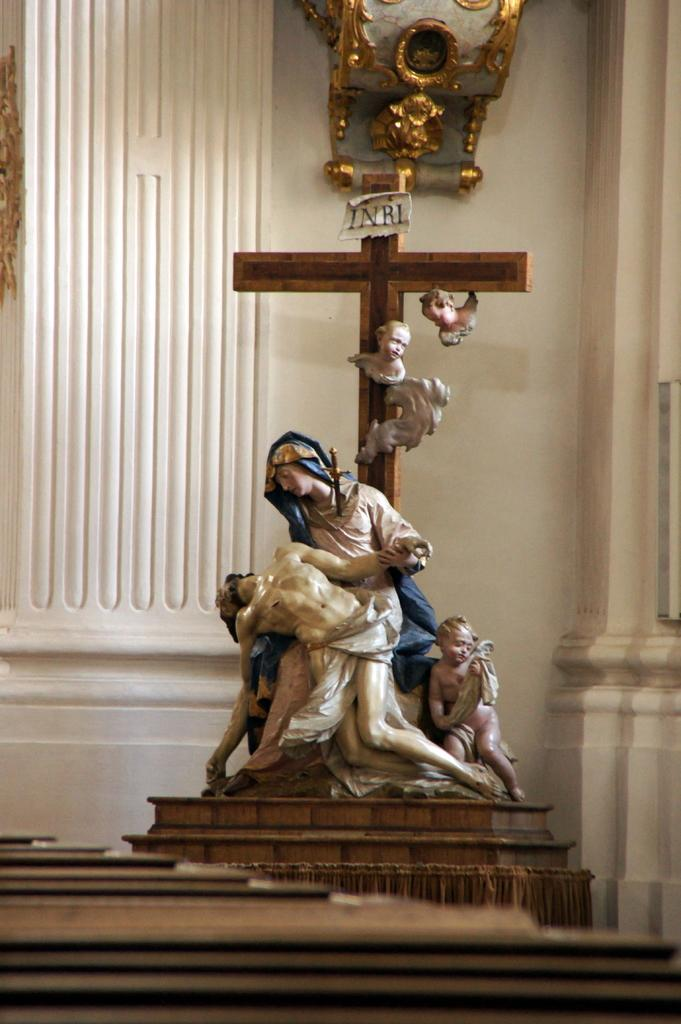What religious symbol can be seen in the image? There is a Christian cross symbol in the image. What other objects are present in the image? There are statues in the image. Can you describe the object attached to the wall in the background? Unfortunately, the facts provided do not give enough information to describe the object attached to the wall in the background. What color is the wall in the background of the image? The wall in the background is in cream color. What type of bone is visible in the image? There is no bone present in the image. Can you tell me how many rifles are depicted in the image? There are no rifles depicted in the image. 